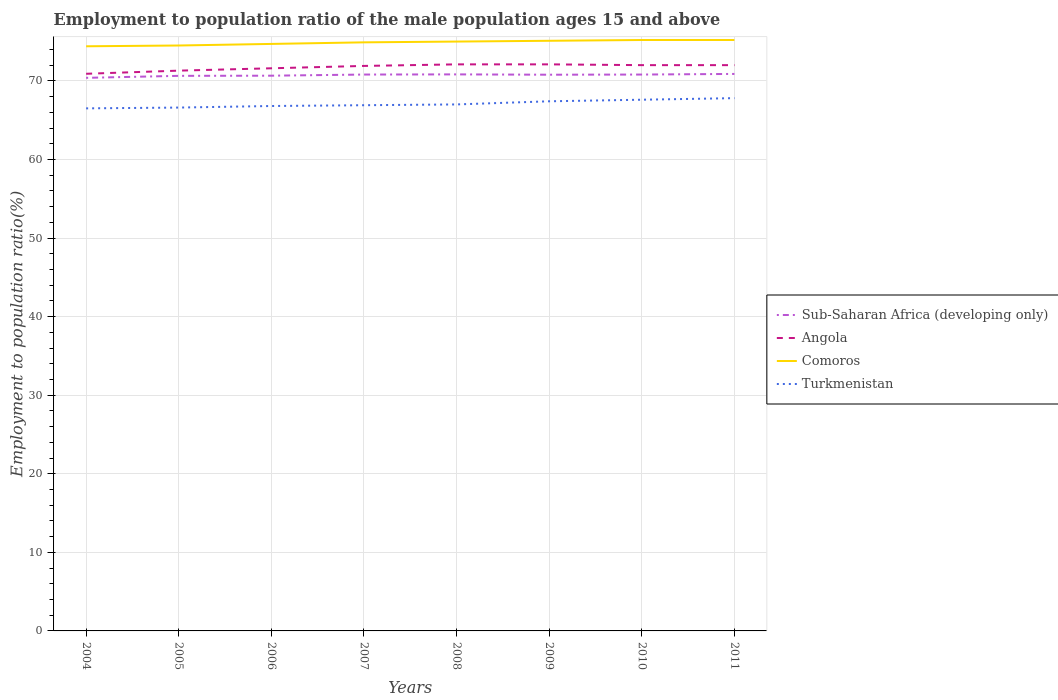How many different coloured lines are there?
Your response must be concise. 4. Does the line corresponding to Comoros intersect with the line corresponding to Angola?
Offer a terse response. No. Is the number of lines equal to the number of legend labels?
Offer a very short reply. Yes. Across all years, what is the maximum employment to population ratio in Sub-Saharan Africa (developing only)?
Make the answer very short. 70.38. In which year was the employment to population ratio in Sub-Saharan Africa (developing only) maximum?
Offer a very short reply. 2004. What is the difference between the highest and the second highest employment to population ratio in Turkmenistan?
Provide a succinct answer. 1.3. Is the employment to population ratio in Sub-Saharan Africa (developing only) strictly greater than the employment to population ratio in Comoros over the years?
Give a very brief answer. Yes. How many lines are there?
Provide a succinct answer. 4. How many years are there in the graph?
Offer a very short reply. 8. What is the difference between two consecutive major ticks on the Y-axis?
Offer a very short reply. 10. Does the graph contain any zero values?
Provide a succinct answer. No. Does the graph contain grids?
Keep it short and to the point. Yes. What is the title of the graph?
Provide a succinct answer. Employment to population ratio of the male population ages 15 and above. Does "Nepal" appear as one of the legend labels in the graph?
Make the answer very short. No. What is the label or title of the X-axis?
Your response must be concise. Years. What is the Employment to population ratio(%) in Sub-Saharan Africa (developing only) in 2004?
Provide a short and direct response. 70.38. What is the Employment to population ratio(%) in Angola in 2004?
Provide a succinct answer. 70.9. What is the Employment to population ratio(%) in Comoros in 2004?
Give a very brief answer. 74.4. What is the Employment to population ratio(%) in Turkmenistan in 2004?
Provide a succinct answer. 66.5. What is the Employment to population ratio(%) in Sub-Saharan Africa (developing only) in 2005?
Give a very brief answer. 70.64. What is the Employment to population ratio(%) of Angola in 2005?
Your response must be concise. 71.3. What is the Employment to population ratio(%) of Comoros in 2005?
Provide a short and direct response. 74.5. What is the Employment to population ratio(%) of Turkmenistan in 2005?
Give a very brief answer. 66.6. What is the Employment to population ratio(%) of Sub-Saharan Africa (developing only) in 2006?
Your answer should be very brief. 70.66. What is the Employment to population ratio(%) of Angola in 2006?
Your answer should be very brief. 71.6. What is the Employment to population ratio(%) of Comoros in 2006?
Keep it short and to the point. 74.7. What is the Employment to population ratio(%) of Turkmenistan in 2006?
Ensure brevity in your answer.  66.8. What is the Employment to population ratio(%) of Sub-Saharan Africa (developing only) in 2007?
Give a very brief answer. 70.8. What is the Employment to population ratio(%) of Angola in 2007?
Your response must be concise. 71.9. What is the Employment to population ratio(%) in Comoros in 2007?
Make the answer very short. 74.9. What is the Employment to population ratio(%) in Turkmenistan in 2007?
Make the answer very short. 66.9. What is the Employment to population ratio(%) of Sub-Saharan Africa (developing only) in 2008?
Ensure brevity in your answer.  70.82. What is the Employment to population ratio(%) of Angola in 2008?
Offer a very short reply. 72.1. What is the Employment to population ratio(%) in Comoros in 2008?
Provide a succinct answer. 75. What is the Employment to population ratio(%) in Sub-Saharan Africa (developing only) in 2009?
Your answer should be compact. 70.78. What is the Employment to population ratio(%) in Angola in 2009?
Offer a terse response. 72.1. What is the Employment to population ratio(%) of Comoros in 2009?
Provide a short and direct response. 75.1. What is the Employment to population ratio(%) in Turkmenistan in 2009?
Keep it short and to the point. 67.4. What is the Employment to population ratio(%) of Sub-Saharan Africa (developing only) in 2010?
Ensure brevity in your answer.  70.8. What is the Employment to population ratio(%) in Angola in 2010?
Ensure brevity in your answer.  72. What is the Employment to population ratio(%) in Comoros in 2010?
Provide a succinct answer. 75.2. What is the Employment to population ratio(%) of Turkmenistan in 2010?
Provide a succinct answer. 67.6. What is the Employment to population ratio(%) of Sub-Saharan Africa (developing only) in 2011?
Your response must be concise. 70.88. What is the Employment to population ratio(%) in Angola in 2011?
Provide a short and direct response. 72. What is the Employment to population ratio(%) in Comoros in 2011?
Offer a very short reply. 75.2. What is the Employment to population ratio(%) of Turkmenistan in 2011?
Offer a terse response. 67.8. Across all years, what is the maximum Employment to population ratio(%) in Sub-Saharan Africa (developing only)?
Provide a short and direct response. 70.88. Across all years, what is the maximum Employment to population ratio(%) in Angola?
Give a very brief answer. 72.1. Across all years, what is the maximum Employment to population ratio(%) in Comoros?
Provide a short and direct response. 75.2. Across all years, what is the maximum Employment to population ratio(%) in Turkmenistan?
Your answer should be compact. 67.8. Across all years, what is the minimum Employment to population ratio(%) in Sub-Saharan Africa (developing only)?
Your response must be concise. 70.38. Across all years, what is the minimum Employment to population ratio(%) in Angola?
Your answer should be very brief. 70.9. Across all years, what is the minimum Employment to population ratio(%) of Comoros?
Ensure brevity in your answer.  74.4. Across all years, what is the minimum Employment to population ratio(%) in Turkmenistan?
Your response must be concise. 66.5. What is the total Employment to population ratio(%) of Sub-Saharan Africa (developing only) in the graph?
Make the answer very short. 565.77. What is the total Employment to population ratio(%) of Angola in the graph?
Offer a terse response. 573.9. What is the total Employment to population ratio(%) in Comoros in the graph?
Ensure brevity in your answer.  599. What is the total Employment to population ratio(%) of Turkmenistan in the graph?
Give a very brief answer. 536.6. What is the difference between the Employment to population ratio(%) of Sub-Saharan Africa (developing only) in 2004 and that in 2005?
Ensure brevity in your answer.  -0.25. What is the difference between the Employment to population ratio(%) in Comoros in 2004 and that in 2005?
Your response must be concise. -0.1. What is the difference between the Employment to population ratio(%) in Sub-Saharan Africa (developing only) in 2004 and that in 2006?
Your response must be concise. -0.27. What is the difference between the Employment to population ratio(%) in Comoros in 2004 and that in 2006?
Offer a very short reply. -0.3. What is the difference between the Employment to population ratio(%) in Turkmenistan in 2004 and that in 2006?
Make the answer very short. -0.3. What is the difference between the Employment to population ratio(%) in Sub-Saharan Africa (developing only) in 2004 and that in 2007?
Offer a very short reply. -0.42. What is the difference between the Employment to population ratio(%) of Angola in 2004 and that in 2007?
Provide a short and direct response. -1. What is the difference between the Employment to population ratio(%) of Turkmenistan in 2004 and that in 2007?
Give a very brief answer. -0.4. What is the difference between the Employment to population ratio(%) in Sub-Saharan Africa (developing only) in 2004 and that in 2008?
Give a very brief answer. -0.44. What is the difference between the Employment to population ratio(%) in Angola in 2004 and that in 2008?
Your response must be concise. -1.2. What is the difference between the Employment to population ratio(%) of Sub-Saharan Africa (developing only) in 2004 and that in 2009?
Your answer should be compact. -0.4. What is the difference between the Employment to population ratio(%) in Comoros in 2004 and that in 2009?
Your response must be concise. -0.7. What is the difference between the Employment to population ratio(%) in Turkmenistan in 2004 and that in 2009?
Keep it short and to the point. -0.9. What is the difference between the Employment to population ratio(%) in Sub-Saharan Africa (developing only) in 2004 and that in 2010?
Give a very brief answer. -0.42. What is the difference between the Employment to population ratio(%) of Angola in 2004 and that in 2010?
Your answer should be very brief. -1.1. What is the difference between the Employment to population ratio(%) of Turkmenistan in 2004 and that in 2010?
Offer a very short reply. -1.1. What is the difference between the Employment to population ratio(%) of Sub-Saharan Africa (developing only) in 2004 and that in 2011?
Your answer should be compact. -0.5. What is the difference between the Employment to population ratio(%) of Angola in 2004 and that in 2011?
Your answer should be very brief. -1.1. What is the difference between the Employment to population ratio(%) of Sub-Saharan Africa (developing only) in 2005 and that in 2006?
Give a very brief answer. -0.02. What is the difference between the Employment to population ratio(%) of Sub-Saharan Africa (developing only) in 2005 and that in 2007?
Offer a terse response. -0.17. What is the difference between the Employment to population ratio(%) in Comoros in 2005 and that in 2007?
Give a very brief answer. -0.4. What is the difference between the Employment to population ratio(%) in Turkmenistan in 2005 and that in 2007?
Ensure brevity in your answer.  -0.3. What is the difference between the Employment to population ratio(%) of Sub-Saharan Africa (developing only) in 2005 and that in 2008?
Offer a very short reply. -0.19. What is the difference between the Employment to population ratio(%) of Angola in 2005 and that in 2008?
Offer a terse response. -0.8. What is the difference between the Employment to population ratio(%) in Turkmenistan in 2005 and that in 2008?
Offer a very short reply. -0.4. What is the difference between the Employment to population ratio(%) of Sub-Saharan Africa (developing only) in 2005 and that in 2009?
Give a very brief answer. -0.14. What is the difference between the Employment to population ratio(%) in Comoros in 2005 and that in 2009?
Ensure brevity in your answer.  -0.6. What is the difference between the Employment to population ratio(%) of Turkmenistan in 2005 and that in 2009?
Provide a short and direct response. -0.8. What is the difference between the Employment to population ratio(%) of Sub-Saharan Africa (developing only) in 2005 and that in 2010?
Your answer should be very brief. -0.17. What is the difference between the Employment to population ratio(%) of Angola in 2005 and that in 2010?
Provide a short and direct response. -0.7. What is the difference between the Employment to population ratio(%) in Sub-Saharan Africa (developing only) in 2005 and that in 2011?
Provide a short and direct response. -0.24. What is the difference between the Employment to population ratio(%) of Turkmenistan in 2005 and that in 2011?
Keep it short and to the point. -1.2. What is the difference between the Employment to population ratio(%) of Sub-Saharan Africa (developing only) in 2006 and that in 2007?
Your answer should be compact. -0.15. What is the difference between the Employment to population ratio(%) of Comoros in 2006 and that in 2007?
Ensure brevity in your answer.  -0.2. What is the difference between the Employment to population ratio(%) of Sub-Saharan Africa (developing only) in 2006 and that in 2008?
Your response must be concise. -0.17. What is the difference between the Employment to population ratio(%) of Comoros in 2006 and that in 2008?
Offer a very short reply. -0.3. What is the difference between the Employment to population ratio(%) in Sub-Saharan Africa (developing only) in 2006 and that in 2009?
Make the answer very short. -0.12. What is the difference between the Employment to population ratio(%) in Angola in 2006 and that in 2009?
Offer a terse response. -0.5. What is the difference between the Employment to population ratio(%) in Comoros in 2006 and that in 2009?
Provide a short and direct response. -0.4. What is the difference between the Employment to population ratio(%) in Turkmenistan in 2006 and that in 2009?
Offer a terse response. -0.6. What is the difference between the Employment to population ratio(%) in Sub-Saharan Africa (developing only) in 2006 and that in 2010?
Give a very brief answer. -0.15. What is the difference between the Employment to population ratio(%) in Comoros in 2006 and that in 2010?
Make the answer very short. -0.5. What is the difference between the Employment to population ratio(%) of Turkmenistan in 2006 and that in 2010?
Your answer should be very brief. -0.8. What is the difference between the Employment to population ratio(%) of Sub-Saharan Africa (developing only) in 2006 and that in 2011?
Ensure brevity in your answer.  -0.22. What is the difference between the Employment to population ratio(%) in Angola in 2006 and that in 2011?
Your response must be concise. -0.4. What is the difference between the Employment to population ratio(%) in Sub-Saharan Africa (developing only) in 2007 and that in 2008?
Offer a very short reply. -0.02. What is the difference between the Employment to population ratio(%) in Angola in 2007 and that in 2008?
Your answer should be compact. -0.2. What is the difference between the Employment to population ratio(%) in Turkmenistan in 2007 and that in 2008?
Give a very brief answer. -0.1. What is the difference between the Employment to population ratio(%) of Sub-Saharan Africa (developing only) in 2007 and that in 2009?
Your response must be concise. 0.02. What is the difference between the Employment to population ratio(%) in Angola in 2007 and that in 2009?
Make the answer very short. -0.2. What is the difference between the Employment to population ratio(%) of Sub-Saharan Africa (developing only) in 2007 and that in 2010?
Offer a terse response. -0. What is the difference between the Employment to population ratio(%) of Comoros in 2007 and that in 2010?
Keep it short and to the point. -0.3. What is the difference between the Employment to population ratio(%) in Sub-Saharan Africa (developing only) in 2007 and that in 2011?
Keep it short and to the point. -0.08. What is the difference between the Employment to population ratio(%) of Turkmenistan in 2007 and that in 2011?
Your answer should be very brief. -0.9. What is the difference between the Employment to population ratio(%) in Sub-Saharan Africa (developing only) in 2008 and that in 2009?
Provide a succinct answer. 0.04. What is the difference between the Employment to population ratio(%) of Angola in 2008 and that in 2009?
Provide a succinct answer. 0. What is the difference between the Employment to population ratio(%) in Turkmenistan in 2008 and that in 2009?
Your response must be concise. -0.4. What is the difference between the Employment to population ratio(%) of Sub-Saharan Africa (developing only) in 2008 and that in 2010?
Give a very brief answer. 0.02. What is the difference between the Employment to population ratio(%) of Angola in 2008 and that in 2010?
Make the answer very short. 0.1. What is the difference between the Employment to population ratio(%) of Turkmenistan in 2008 and that in 2010?
Give a very brief answer. -0.6. What is the difference between the Employment to population ratio(%) of Sub-Saharan Africa (developing only) in 2008 and that in 2011?
Provide a succinct answer. -0.06. What is the difference between the Employment to population ratio(%) in Angola in 2008 and that in 2011?
Provide a succinct answer. 0.1. What is the difference between the Employment to population ratio(%) of Sub-Saharan Africa (developing only) in 2009 and that in 2010?
Your response must be concise. -0.02. What is the difference between the Employment to population ratio(%) of Comoros in 2009 and that in 2010?
Your response must be concise. -0.1. What is the difference between the Employment to population ratio(%) in Sub-Saharan Africa (developing only) in 2009 and that in 2011?
Keep it short and to the point. -0.1. What is the difference between the Employment to population ratio(%) of Sub-Saharan Africa (developing only) in 2010 and that in 2011?
Provide a short and direct response. -0.08. What is the difference between the Employment to population ratio(%) of Angola in 2010 and that in 2011?
Your answer should be very brief. 0. What is the difference between the Employment to population ratio(%) in Sub-Saharan Africa (developing only) in 2004 and the Employment to population ratio(%) in Angola in 2005?
Keep it short and to the point. -0.92. What is the difference between the Employment to population ratio(%) in Sub-Saharan Africa (developing only) in 2004 and the Employment to population ratio(%) in Comoros in 2005?
Offer a terse response. -4.12. What is the difference between the Employment to population ratio(%) of Sub-Saharan Africa (developing only) in 2004 and the Employment to population ratio(%) of Turkmenistan in 2005?
Your response must be concise. 3.78. What is the difference between the Employment to population ratio(%) in Angola in 2004 and the Employment to population ratio(%) in Comoros in 2005?
Offer a very short reply. -3.6. What is the difference between the Employment to population ratio(%) of Sub-Saharan Africa (developing only) in 2004 and the Employment to population ratio(%) of Angola in 2006?
Offer a terse response. -1.22. What is the difference between the Employment to population ratio(%) in Sub-Saharan Africa (developing only) in 2004 and the Employment to population ratio(%) in Comoros in 2006?
Your response must be concise. -4.32. What is the difference between the Employment to population ratio(%) in Sub-Saharan Africa (developing only) in 2004 and the Employment to population ratio(%) in Turkmenistan in 2006?
Ensure brevity in your answer.  3.58. What is the difference between the Employment to population ratio(%) of Comoros in 2004 and the Employment to population ratio(%) of Turkmenistan in 2006?
Provide a succinct answer. 7.6. What is the difference between the Employment to population ratio(%) of Sub-Saharan Africa (developing only) in 2004 and the Employment to population ratio(%) of Angola in 2007?
Offer a very short reply. -1.52. What is the difference between the Employment to population ratio(%) of Sub-Saharan Africa (developing only) in 2004 and the Employment to population ratio(%) of Comoros in 2007?
Ensure brevity in your answer.  -4.52. What is the difference between the Employment to population ratio(%) in Sub-Saharan Africa (developing only) in 2004 and the Employment to population ratio(%) in Turkmenistan in 2007?
Keep it short and to the point. 3.48. What is the difference between the Employment to population ratio(%) in Angola in 2004 and the Employment to population ratio(%) in Comoros in 2007?
Give a very brief answer. -4. What is the difference between the Employment to population ratio(%) of Angola in 2004 and the Employment to population ratio(%) of Turkmenistan in 2007?
Provide a succinct answer. 4. What is the difference between the Employment to population ratio(%) of Comoros in 2004 and the Employment to population ratio(%) of Turkmenistan in 2007?
Your answer should be compact. 7.5. What is the difference between the Employment to population ratio(%) of Sub-Saharan Africa (developing only) in 2004 and the Employment to population ratio(%) of Angola in 2008?
Your response must be concise. -1.72. What is the difference between the Employment to population ratio(%) of Sub-Saharan Africa (developing only) in 2004 and the Employment to population ratio(%) of Comoros in 2008?
Your answer should be compact. -4.62. What is the difference between the Employment to population ratio(%) of Sub-Saharan Africa (developing only) in 2004 and the Employment to population ratio(%) of Turkmenistan in 2008?
Make the answer very short. 3.38. What is the difference between the Employment to population ratio(%) of Angola in 2004 and the Employment to population ratio(%) of Comoros in 2008?
Offer a terse response. -4.1. What is the difference between the Employment to population ratio(%) of Angola in 2004 and the Employment to population ratio(%) of Turkmenistan in 2008?
Provide a short and direct response. 3.9. What is the difference between the Employment to population ratio(%) in Sub-Saharan Africa (developing only) in 2004 and the Employment to population ratio(%) in Angola in 2009?
Provide a succinct answer. -1.72. What is the difference between the Employment to population ratio(%) in Sub-Saharan Africa (developing only) in 2004 and the Employment to population ratio(%) in Comoros in 2009?
Your answer should be compact. -4.72. What is the difference between the Employment to population ratio(%) of Sub-Saharan Africa (developing only) in 2004 and the Employment to population ratio(%) of Turkmenistan in 2009?
Ensure brevity in your answer.  2.98. What is the difference between the Employment to population ratio(%) in Angola in 2004 and the Employment to population ratio(%) in Comoros in 2009?
Your answer should be very brief. -4.2. What is the difference between the Employment to population ratio(%) in Comoros in 2004 and the Employment to population ratio(%) in Turkmenistan in 2009?
Offer a very short reply. 7. What is the difference between the Employment to population ratio(%) of Sub-Saharan Africa (developing only) in 2004 and the Employment to population ratio(%) of Angola in 2010?
Make the answer very short. -1.62. What is the difference between the Employment to population ratio(%) in Sub-Saharan Africa (developing only) in 2004 and the Employment to population ratio(%) in Comoros in 2010?
Your response must be concise. -4.82. What is the difference between the Employment to population ratio(%) in Sub-Saharan Africa (developing only) in 2004 and the Employment to population ratio(%) in Turkmenistan in 2010?
Provide a short and direct response. 2.78. What is the difference between the Employment to population ratio(%) in Angola in 2004 and the Employment to population ratio(%) in Turkmenistan in 2010?
Ensure brevity in your answer.  3.3. What is the difference between the Employment to population ratio(%) in Comoros in 2004 and the Employment to population ratio(%) in Turkmenistan in 2010?
Make the answer very short. 6.8. What is the difference between the Employment to population ratio(%) of Sub-Saharan Africa (developing only) in 2004 and the Employment to population ratio(%) of Angola in 2011?
Ensure brevity in your answer.  -1.62. What is the difference between the Employment to population ratio(%) in Sub-Saharan Africa (developing only) in 2004 and the Employment to population ratio(%) in Comoros in 2011?
Keep it short and to the point. -4.82. What is the difference between the Employment to population ratio(%) in Sub-Saharan Africa (developing only) in 2004 and the Employment to population ratio(%) in Turkmenistan in 2011?
Give a very brief answer. 2.58. What is the difference between the Employment to population ratio(%) of Sub-Saharan Africa (developing only) in 2005 and the Employment to population ratio(%) of Angola in 2006?
Provide a succinct answer. -0.96. What is the difference between the Employment to population ratio(%) of Sub-Saharan Africa (developing only) in 2005 and the Employment to population ratio(%) of Comoros in 2006?
Your answer should be compact. -4.06. What is the difference between the Employment to population ratio(%) of Sub-Saharan Africa (developing only) in 2005 and the Employment to population ratio(%) of Turkmenistan in 2006?
Keep it short and to the point. 3.84. What is the difference between the Employment to population ratio(%) of Angola in 2005 and the Employment to population ratio(%) of Comoros in 2006?
Make the answer very short. -3.4. What is the difference between the Employment to population ratio(%) of Comoros in 2005 and the Employment to population ratio(%) of Turkmenistan in 2006?
Ensure brevity in your answer.  7.7. What is the difference between the Employment to population ratio(%) in Sub-Saharan Africa (developing only) in 2005 and the Employment to population ratio(%) in Angola in 2007?
Offer a terse response. -1.26. What is the difference between the Employment to population ratio(%) of Sub-Saharan Africa (developing only) in 2005 and the Employment to population ratio(%) of Comoros in 2007?
Keep it short and to the point. -4.26. What is the difference between the Employment to population ratio(%) in Sub-Saharan Africa (developing only) in 2005 and the Employment to population ratio(%) in Turkmenistan in 2007?
Keep it short and to the point. 3.74. What is the difference between the Employment to population ratio(%) in Angola in 2005 and the Employment to population ratio(%) in Turkmenistan in 2007?
Provide a succinct answer. 4.4. What is the difference between the Employment to population ratio(%) in Sub-Saharan Africa (developing only) in 2005 and the Employment to population ratio(%) in Angola in 2008?
Ensure brevity in your answer.  -1.46. What is the difference between the Employment to population ratio(%) of Sub-Saharan Africa (developing only) in 2005 and the Employment to population ratio(%) of Comoros in 2008?
Your response must be concise. -4.36. What is the difference between the Employment to population ratio(%) of Sub-Saharan Africa (developing only) in 2005 and the Employment to population ratio(%) of Turkmenistan in 2008?
Keep it short and to the point. 3.64. What is the difference between the Employment to population ratio(%) of Angola in 2005 and the Employment to population ratio(%) of Turkmenistan in 2008?
Provide a succinct answer. 4.3. What is the difference between the Employment to population ratio(%) in Comoros in 2005 and the Employment to population ratio(%) in Turkmenistan in 2008?
Your answer should be very brief. 7.5. What is the difference between the Employment to population ratio(%) in Sub-Saharan Africa (developing only) in 2005 and the Employment to population ratio(%) in Angola in 2009?
Your answer should be very brief. -1.46. What is the difference between the Employment to population ratio(%) in Sub-Saharan Africa (developing only) in 2005 and the Employment to population ratio(%) in Comoros in 2009?
Give a very brief answer. -4.46. What is the difference between the Employment to population ratio(%) of Sub-Saharan Africa (developing only) in 2005 and the Employment to population ratio(%) of Turkmenistan in 2009?
Offer a very short reply. 3.24. What is the difference between the Employment to population ratio(%) of Angola in 2005 and the Employment to population ratio(%) of Comoros in 2009?
Keep it short and to the point. -3.8. What is the difference between the Employment to population ratio(%) in Sub-Saharan Africa (developing only) in 2005 and the Employment to population ratio(%) in Angola in 2010?
Your answer should be very brief. -1.36. What is the difference between the Employment to population ratio(%) in Sub-Saharan Africa (developing only) in 2005 and the Employment to population ratio(%) in Comoros in 2010?
Provide a short and direct response. -4.56. What is the difference between the Employment to population ratio(%) of Sub-Saharan Africa (developing only) in 2005 and the Employment to population ratio(%) of Turkmenistan in 2010?
Offer a terse response. 3.04. What is the difference between the Employment to population ratio(%) of Angola in 2005 and the Employment to population ratio(%) of Comoros in 2010?
Ensure brevity in your answer.  -3.9. What is the difference between the Employment to population ratio(%) of Comoros in 2005 and the Employment to population ratio(%) of Turkmenistan in 2010?
Offer a very short reply. 6.9. What is the difference between the Employment to population ratio(%) in Sub-Saharan Africa (developing only) in 2005 and the Employment to population ratio(%) in Angola in 2011?
Give a very brief answer. -1.36. What is the difference between the Employment to population ratio(%) of Sub-Saharan Africa (developing only) in 2005 and the Employment to population ratio(%) of Comoros in 2011?
Offer a terse response. -4.56. What is the difference between the Employment to population ratio(%) of Sub-Saharan Africa (developing only) in 2005 and the Employment to population ratio(%) of Turkmenistan in 2011?
Your response must be concise. 2.84. What is the difference between the Employment to population ratio(%) of Angola in 2005 and the Employment to population ratio(%) of Comoros in 2011?
Your answer should be compact. -3.9. What is the difference between the Employment to population ratio(%) in Comoros in 2005 and the Employment to population ratio(%) in Turkmenistan in 2011?
Your response must be concise. 6.7. What is the difference between the Employment to population ratio(%) of Sub-Saharan Africa (developing only) in 2006 and the Employment to population ratio(%) of Angola in 2007?
Your response must be concise. -1.24. What is the difference between the Employment to population ratio(%) of Sub-Saharan Africa (developing only) in 2006 and the Employment to population ratio(%) of Comoros in 2007?
Keep it short and to the point. -4.24. What is the difference between the Employment to population ratio(%) in Sub-Saharan Africa (developing only) in 2006 and the Employment to population ratio(%) in Turkmenistan in 2007?
Provide a succinct answer. 3.76. What is the difference between the Employment to population ratio(%) of Angola in 2006 and the Employment to population ratio(%) of Comoros in 2007?
Ensure brevity in your answer.  -3.3. What is the difference between the Employment to population ratio(%) in Angola in 2006 and the Employment to population ratio(%) in Turkmenistan in 2007?
Provide a short and direct response. 4.7. What is the difference between the Employment to population ratio(%) in Comoros in 2006 and the Employment to population ratio(%) in Turkmenistan in 2007?
Offer a very short reply. 7.8. What is the difference between the Employment to population ratio(%) of Sub-Saharan Africa (developing only) in 2006 and the Employment to population ratio(%) of Angola in 2008?
Provide a short and direct response. -1.44. What is the difference between the Employment to population ratio(%) of Sub-Saharan Africa (developing only) in 2006 and the Employment to population ratio(%) of Comoros in 2008?
Offer a very short reply. -4.34. What is the difference between the Employment to population ratio(%) in Sub-Saharan Africa (developing only) in 2006 and the Employment to population ratio(%) in Turkmenistan in 2008?
Keep it short and to the point. 3.66. What is the difference between the Employment to population ratio(%) in Sub-Saharan Africa (developing only) in 2006 and the Employment to population ratio(%) in Angola in 2009?
Your answer should be very brief. -1.44. What is the difference between the Employment to population ratio(%) of Sub-Saharan Africa (developing only) in 2006 and the Employment to population ratio(%) of Comoros in 2009?
Give a very brief answer. -4.44. What is the difference between the Employment to population ratio(%) in Sub-Saharan Africa (developing only) in 2006 and the Employment to population ratio(%) in Turkmenistan in 2009?
Ensure brevity in your answer.  3.26. What is the difference between the Employment to population ratio(%) in Angola in 2006 and the Employment to population ratio(%) in Comoros in 2009?
Provide a short and direct response. -3.5. What is the difference between the Employment to population ratio(%) in Angola in 2006 and the Employment to population ratio(%) in Turkmenistan in 2009?
Offer a terse response. 4.2. What is the difference between the Employment to population ratio(%) of Sub-Saharan Africa (developing only) in 2006 and the Employment to population ratio(%) of Angola in 2010?
Offer a terse response. -1.34. What is the difference between the Employment to population ratio(%) in Sub-Saharan Africa (developing only) in 2006 and the Employment to population ratio(%) in Comoros in 2010?
Your answer should be very brief. -4.54. What is the difference between the Employment to population ratio(%) of Sub-Saharan Africa (developing only) in 2006 and the Employment to population ratio(%) of Turkmenistan in 2010?
Your answer should be compact. 3.06. What is the difference between the Employment to population ratio(%) of Angola in 2006 and the Employment to population ratio(%) of Comoros in 2010?
Provide a short and direct response. -3.6. What is the difference between the Employment to population ratio(%) in Sub-Saharan Africa (developing only) in 2006 and the Employment to population ratio(%) in Angola in 2011?
Make the answer very short. -1.34. What is the difference between the Employment to population ratio(%) of Sub-Saharan Africa (developing only) in 2006 and the Employment to population ratio(%) of Comoros in 2011?
Your answer should be compact. -4.54. What is the difference between the Employment to population ratio(%) in Sub-Saharan Africa (developing only) in 2006 and the Employment to population ratio(%) in Turkmenistan in 2011?
Offer a very short reply. 2.86. What is the difference between the Employment to population ratio(%) in Comoros in 2006 and the Employment to population ratio(%) in Turkmenistan in 2011?
Make the answer very short. 6.9. What is the difference between the Employment to population ratio(%) in Sub-Saharan Africa (developing only) in 2007 and the Employment to population ratio(%) in Angola in 2008?
Make the answer very short. -1.3. What is the difference between the Employment to population ratio(%) in Sub-Saharan Africa (developing only) in 2007 and the Employment to population ratio(%) in Comoros in 2008?
Offer a terse response. -4.2. What is the difference between the Employment to population ratio(%) in Sub-Saharan Africa (developing only) in 2007 and the Employment to population ratio(%) in Turkmenistan in 2008?
Provide a short and direct response. 3.8. What is the difference between the Employment to population ratio(%) of Comoros in 2007 and the Employment to population ratio(%) of Turkmenistan in 2008?
Keep it short and to the point. 7.9. What is the difference between the Employment to population ratio(%) of Sub-Saharan Africa (developing only) in 2007 and the Employment to population ratio(%) of Angola in 2009?
Keep it short and to the point. -1.3. What is the difference between the Employment to population ratio(%) of Sub-Saharan Africa (developing only) in 2007 and the Employment to population ratio(%) of Comoros in 2009?
Ensure brevity in your answer.  -4.3. What is the difference between the Employment to population ratio(%) of Sub-Saharan Africa (developing only) in 2007 and the Employment to population ratio(%) of Turkmenistan in 2009?
Provide a short and direct response. 3.4. What is the difference between the Employment to population ratio(%) of Angola in 2007 and the Employment to population ratio(%) of Turkmenistan in 2009?
Give a very brief answer. 4.5. What is the difference between the Employment to population ratio(%) in Comoros in 2007 and the Employment to population ratio(%) in Turkmenistan in 2009?
Provide a short and direct response. 7.5. What is the difference between the Employment to population ratio(%) in Sub-Saharan Africa (developing only) in 2007 and the Employment to population ratio(%) in Angola in 2010?
Ensure brevity in your answer.  -1.2. What is the difference between the Employment to population ratio(%) of Sub-Saharan Africa (developing only) in 2007 and the Employment to population ratio(%) of Comoros in 2010?
Offer a terse response. -4.4. What is the difference between the Employment to population ratio(%) of Sub-Saharan Africa (developing only) in 2007 and the Employment to population ratio(%) of Turkmenistan in 2010?
Your answer should be very brief. 3.2. What is the difference between the Employment to population ratio(%) of Sub-Saharan Africa (developing only) in 2007 and the Employment to population ratio(%) of Angola in 2011?
Your response must be concise. -1.2. What is the difference between the Employment to population ratio(%) in Sub-Saharan Africa (developing only) in 2007 and the Employment to population ratio(%) in Comoros in 2011?
Provide a succinct answer. -4.4. What is the difference between the Employment to population ratio(%) of Sub-Saharan Africa (developing only) in 2007 and the Employment to population ratio(%) of Turkmenistan in 2011?
Your response must be concise. 3. What is the difference between the Employment to population ratio(%) in Comoros in 2007 and the Employment to population ratio(%) in Turkmenistan in 2011?
Provide a succinct answer. 7.1. What is the difference between the Employment to population ratio(%) of Sub-Saharan Africa (developing only) in 2008 and the Employment to population ratio(%) of Angola in 2009?
Offer a very short reply. -1.28. What is the difference between the Employment to population ratio(%) in Sub-Saharan Africa (developing only) in 2008 and the Employment to population ratio(%) in Comoros in 2009?
Offer a terse response. -4.28. What is the difference between the Employment to population ratio(%) in Sub-Saharan Africa (developing only) in 2008 and the Employment to population ratio(%) in Turkmenistan in 2009?
Your answer should be compact. 3.42. What is the difference between the Employment to population ratio(%) of Comoros in 2008 and the Employment to population ratio(%) of Turkmenistan in 2009?
Your answer should be very brief. 7.6. What is the difference between the Employment to population ratio(%) of Sub-Saharan Africa (developing only) in 2008 and the Employment to population ratio(%) of Angola in 2010?
Your answer should be very brief. -1.18. What is the difference between the Employment to population ratio(%) of Sub-Saharan Africa (developing only) in 2008 and the Employment to population ratio(%) of Comoros in 2010?
Your response must be concise. -4.38. What is the difference between the Employment to population ratio(%) in Sub-Saharan Africa (developing only) in 2008 and the Employment to population ratio(%) in Turkmenistan in 2010?
Keep it short and to the point. 3.22. What is the difference between the Employment to population ratio(%) of Angola in 2008 and the Employment to population ratio(%) of Turkmenistan in 2010?
Provide a short and direct response. 4.5. What is the difference between the Employment to population ratio(%) in Comoros in 2008 and the Employment to population ratio(%) in Turkmenistan in 2010?
Keep it short and to the point. 7.4. What is the difference between the Employment to population ratio(%) of Sub-Saharan Africa (developing only) in 2008 and the Employment to population ratio(%) of Angola in 2011?
Ensure brevity in your answer.  -1.18. What is the difference between the Employment to population ratio(%) in Sub-Saharan Africa (developing only) in 2008 and the Employment to population ratio(%) in Comoros in 2011?
Your answer should be compact. -4.38. What is the difference between the Employment to population ratio(%) in Sub-Saharan Africa (developing only) in 2008 and the Employment to population ratio(%) in Turkmenistan in 2011?
Ensure brevity in your answer.  3.02. What is the difference between the Employment to population ratio(%) in Angola in 2008 and the Employment to population ratio(%) in Turkmenistan in 2011?
Provide a succinct answer. 4.3. What is the difference between the Employment to population ratio(%) in Sub-Saharan Africa (developing only) in 2009 and the Employment to population ratio(%) in Angola in 2010?
Offer a terse response. -1.22. What is the difference between the Employment to population ratio(%) of Sub-Saharan Africa (developing only) in 2009 and the Employment to population ratio(%) of Comoros in 2010?
Your response must be concise. -4.42. What is the difference between the Employment to population ratio(%) of Sub-Saharan Africa (developing only) in 2009 and the Employment to population ratio(%) of Turkmenistan in 2010?
Make the answer very short. 3.18. What is the difference between the Employment to population ratio(%) in Angola in 2009 and the Employment to population ratio(%) in Comoros in 2010?
Ensure brevity in your answer.  -3.1. What is the difference between the Employment to population ratio(%) in Comoros in 2009 and the Employment to population ratio(%) in Turkmenistan in 2010?
Your answer should be very brief. 7.5. What is the difference between the Employment to population ratio(%) in Sub-Saharan Africa (developing only) in 2009 and the Employment to population ratio(%) in Angola in 2011?
Provide a succinct answer. -1.22. What is the difference between the Employment to population ratio(%) of Sub-Saharan Africa (developing only) in 2009 and the Employment to population ratio(%) of Comoros in 2011?
Provide a succinct answer. -4.42. What is the difference between the Employment to population ratio(%) of Sub-Saharan Africa (developing only) in 2009 and the Employment to population ratio(%) of Turkmenistan in 2011?
Provide a short and direct response. 2.98. What is the difference between the Employment to population ratio(%) of Angola in 2009 and the Employment to population ratio(%) of Comoros in 2011?
Your answer should be compact. -3.1. What is the difference between the Employment to population ratio(%) in Sub-Saharan Africa (developing only) in 2010 and the Employment to population ratio(%) in Angola in 2011?
Offer a very short reply. -1.2. What is the difference between the Employment to population ratio(%) of Sub-Saharan Africa (developing only) in 2010 and the Employment to population ratio(%) of Comoros in 2011?
Make the answer very short. -4.4. What is the difference between the Employment to population ratio(%) in Sub-Saharan Africa (developing only) in 2010 and the Employment to population ratio(%) in Turkmenistan in 2011?
Your answer should be compact. 3. What is the difference between the Employment to population ratio(%) of Angola in 2010 and the Employment to population ratio(%) of Turkmenistan in 2011?
Make the answer very short. 4.2. What is the difference between the Employment to population ratio(%) in Comoros in 2010 and the Employment to population ratio(%) in Turkmenistan in 2011?
Your response must be concise. 7.4. What is the average Employment to population ratio(%) of Sub-Saharan Africa (developing only) per year?
Keep it short and to the point. 70.72. What is the average Employment to population ratio(%) in Angola per year?
Your answer should be very brief. 71.74. What is the average Employment to population ratio(%) in Comoros per year?
Make the answer very short. 74.88. What is the average Employment to population ratio(%) of Turkmenistan per year?
Offer a terse response. 67.08. In the year 2004, what is the difference between the Employment to population ratio(%) of Sub-Saharan Africa (developing only) and Employment to population ratio(%) of Angola?
Your answer should be very brief. -0.52. In the year 2004, what is the difference between the Employment to population ratio(%) of Sub-Saharan Africa (developing only) and Employment to population ratio(%) of Comoros?
Offer a terse response. -4.02. In the year 2004, what is the difference between the Employment to population ratio(%) of Sub-Saharan Africa (developing only) and Employment to population ratio(%) of Turkmenistan?
Your response must be concise. 3.88. In the year 2004, what is the difference between the Employment to population ratio(%) of Angola and Employment to population ratio(%) of Turkmenistan?
Your answer should be compact. 4.4. In the year 2004, what is the difference between the Employment to population ratio(%) of Comoros and Employment to population ratio(%) of Turkmenistan?
Your answer should be very brief. 7.9. In the year 2005, what is the difference between the Employment to population ratio(%) in Sub-Saharan Africa (developing only) and Employment to population ratio(%) in Angola?
Your response must be concise. -0.66. In the year 2005, what is the difference between the Employment to population ratio(%) in Sub-Saharan Africa (developing only) and Employment to population ratio(%) in Comoros?
Your answer should be very brief. -3.86. In the year 2005, what is the difference between the Employment to population ratio(%) of Sub-Saharan Africa (developing only) and Employment to population ratio(%) of Turkmenistan?
Ensure brevity in your answer.  4.04. In the year 2005, what is the difference between the Employment to population ratio(%) in Angola and Employment to population ratio(%) in Comoros?
Provide a short and direct response. -3.2. In the year 2006, what is the difference between the Employment to population ratio(%) in Sub-Saharan Africa (developing only) and Employment to population ratio(%) in Angola?
Provide a succinct answer. -0.94. In the year 2006, what is the difference between the Employment to population ratio(%) of Sub-Saharan Africa (developing only) and Employment to population ratio(%) of Comoros?
Offer a very short reply. -4.04. In the year 2006, what is the difference between the Employment to population ratio(%) in Sub-Saharan Africa (developing only) and Employment to population ratio(%) in Turkmenistan?
Your answer should be compact. 3.86. In the year 2006, what is the difference between the Employment to population ratio(%) of Comoros and Employment to population ratio(%) of Turkmenistan?
Provide a succinct answer. 7.9. In the year 2007, what is the difference between the Employment to population ratio(%) of Sub-Saharan Africa (developing only) and Employment to population ratio(%) of Angola?
Your answer should be very brief. -1.1. In the year 2007, what is the difference between the Employment to population ratio(%) of Sub-Saharan Africa (developing only) and Employment to population ratio(%) of Comoros?
Ensure brevity in your answer.  -4.1. In the year 2007, what is the difference between the Employment to population ratio(%) of Sub-Saharan Africa (developing only) and Employment to population ratio(%) of Turkmenistan?
Your response must be concise. 3.9. In the year 2007, what is the difference between the Employment to population ratio(%) in Comoros and Employment to population ratio(%) in Turkmenistan?
Keep it short and to the point. 8. In the year 2008, what is the difference between the Employment to population ratio(%) of Sub-Saharan Africa (developing only) and Employment to population ratio(%) of Angola?
Offer a very short reply. -1.28. In the year 2008, what is the difference between the Employment to population ratio(%) of Sub-Saharan Africa (developing only) and Employment to population ratio(%) of Comoros?
Your answer should be compact. -4.18. In the year 2008, what is the difference between the Employment to population ratio(%) of Sub-Saharan Africa (developing only) and Employment to population ratio(%) of Turkmenistan?
Offer a very short reply. 3.82. In the year 2008, what is the difference between the Employment to population ratio(%) of Angola and Employment to population ratio(%) of Turkmenistan?
Provide a succinct answer. 5.1. In the year 2009, what is the difference between the Employment to population ratio(%) in Sub-Saharan Africa (developing only) and Employment to population ratio(%) in Angola?
Offer a very short reply. -1.32. In the year 2009, what is the difference between the Employment to population ratio(%) of Sub-Saharan Africa (developing only) and Employment to population ratio(%) of Comoros?
Your answer should be very brief. -4.32. In the year 2009, what is the difference between the Employment to population ratio(%) of Sub-Saharan Africa (developing only) and Employment to population ratio(%) of Turkmenistan?
Your response must be concise. 3.38. In the year 2009, what is the difference between the Employment to population ratio(%) of Angola and Employment to population ratio(%) of Turkmenistan?
Give a very brief answer. 4.7. In the year 2010, what is the difference between the Employment to population ratio(%) in Sub-Saharan Africa (developing only) and Employment to population ratio(%) in Angola?
Your response must be concise. -1.2. In the year 2010, what is the difference between the Employment to population ratio(%) of Sub-Saharan Africa (developing only) and Employment to population ratio(%) of Comoros?
Make the answer very short. -4.4. In the year 2010, what is the difference between the Employment to population ratio(%) of Sub-Saharan Africa (developing only) and Employment to population ratio(%) of Turkmenistan?
Your response must be concise. 3.2. In the year 2010, what is the difference between the Employment to population ratio(%) in Comoros and Employment to population ratio(%) in Turkmenistan?
Provide a succinct answer. 7.6. In the year 2011, what is the difference between the Employment to population ratio(%) of Sub-Saharan Africa (developing only) and Employment to population ratio(%) of Angola?
Your answer should be compact. -1.12. In the year 2011, what is the difference between the Employment to population ratio(%) of Sub-Saharan Africa (developing only) and Employment to population ratio(%) of Comoros?
Offer a very short reply. -4.32. In the year 2011, what is the difference between the Employment to population ratio(%) of Sub-Saharan Africa (developing only) and Employment to population ratio(%) of Turkmenistan?
Offer a very short reply. 3.08. In the year 2011, what is the difference between the Employment to population ratio(%) of Angola and Employment to population ratio(%) of Turkmenistan?
Offer a very short reply. 4.2. What is the ratio of the Employment to population ratio(%) of Sub-Saharan Africa (developing only) in 2004 to that in 2005?
Your answer should be very brief. 1. What is the ratio of the Employment to population ratio(%) in Turkmenistan in 2004 to that in 2005?
Your response must be concise. 1. What is the ratio of the Employment to population ratio(%) of Sub-Saharan Africa (developing only) in 2004 to that in 2006?
Ensure brevity in your answer.  1. What is the ratio of the Employment to population ratio(%) in Angola in 2004 to that in 2006?
Make the answer very short. 0.99. What is the ratio of the Employment to population ratio(%) of Comoros in 2004 to that in 2006?
Your answer should be very brief. 1. What is the ratio of the Employment to population ratio(%) of Sub-Saharan Africa (developing only) in 2004 to that in 2007?
Your answer should be very brief. 0.99. What is the ratio of the Employment to population ratio(%) of Angola in 2004 to that in 2007?
Your response must be concise. 0.99. What is the ratio of the Employment to population ratio(%) of Comoros in 2004 to that in 2007?
Ensure brevity in your answer.  0.99. What is the ratio of the Employment to population ratio(%) of Angola in 2004 to that in 2008?
Provide a short and direct response. 0.98. What is the ratio of the Employment to population ratio(%) of Angola in 2004 to that in 2009?
Give a very brief answer. 0.98. What is the ratio of the Employment to population ratio(%) of Comoros in 2004 to that in 2009?
Make the answer very short. 0.99. What is the ratio of the Employment to population ratio(%) in Turkmenistan in 2004 to that in 2009?
Offer a terse response. 0.99. What is the ratio of the Employment to population ratio(%) of Sub-Saharan Africa (developing only) in 2004 to that in 2010?
Give a very brief answer. 0.99. What is the ratio of the Employment to population ratio(%) in Angola in 2004 to that in 2010?
Provide a short and direct response. 0.98. What is the ratio of the Employment to population ratio(%) in Comoros in 2004 to that in 2010?
Your answer should be very brief. 0.99. What is the ratio of the Employment to population ratio(%) in Turkmenistan in 2004 to that in 2010?
Ensure brevity in your answer.  0.98. What is the ratio of the Employment to population ratio(%) in Sub-Saharan Africa (developing only) in 2004 to that in 2011?
Offer a very short reply. 0.99. What is the ratio of the Employment to population ratio(%) in Angola in 2004 to that in 2011?
Your answer should be compact. 0.98. What is the ratio of the Employment to population ratio(%) of Comoros in 2004 to that in 2011?
Make the answer very short. 0.99. What is the ratio of the Employment to population ratio(%) in Turkmenistan in 2004 to that in 2011?
Your answer should be compact. 0.98. What is the ratio of the Employment to population ratio(%) of Sub-Saharan Africa (developing only) in 2005 to that in 2006?
Your answer should be compact. 1. What is the ratio of the Employment to population ratio(%) in Angola in 2005 to that in 2006?
Give a very brief answer. 1. What is the ratio of the Employment to population ratio(%) of Angola in 2005 to that in 2008?
Offer a very short reply. 0.99. What is the ratio of the Employment to population ratio(%) of Turkmenistan in 2005 to that in 2008?
Make the answer very short. 0.99. What is the ratio of the Employment to population ratio(%) of Sub-Saharan Africa (developing only) in 2005 to that in 2009?
Ensure brevity in your answer.  1. What is the ratio of the Employment to population ratio(%) of Angola in 2005 to that in 2009?
Offer a terse response. 0.99. What is the ratio of the Employment to population ratio(%) of Comoros in 2005 to that in 2009?
Your answer should be very brief. 0.99. What is the ratio of the Employment to population ratio(%) of Angola in 2005 to that in 2010?
Offer a very short reply. 0.99. What is the ratio of the Employment to population ratio(%) in Turkmenistan in 2005 to that in 2010?
Provide a short and direct response. 0.99. What is the ratio of the Employment to population ratio(%) in Angola in 2005 to that in 2011?
Make the answer very short. 0.99. What is the ratio of the Employment to population ratio(%) in Turkmenistan in 2005 to that in 2011?
Your answer should be compact. 0.98. What is the ratio of the Employment to population ratio(%) of Comoros in 2006 to that in 2007?
Provide a short and direct response. 1. What is the ratio of the Employment to population ratio(%) in Turkmenistan in 2006 to that in 2007?
Keep it short and to the point. 1. What is the ratio of the Employment to population ratio(%) of Sub-Saharan Africa (developing only) in 2006 to that in 2008?
Ensure brevity in your answer.  1. What is the ratio of the Employment to population ratio(%) of Turkmenistan in 2006 to that in 2008?
Offer a very short reply. 1. What is the ratio of the Employment to population ratio(%) of Sub-Saharan Africa (developing only) in 2006 to that in 2010?
Your answer should be compact. 1. What is the ratio of the Employment to population ratio(%) of Comoros in 2006 to that in 2010?
Offer a very short reply. 0.99. What is the ratio of the Employment to population ratio(%) in Sub-Saharan Africa (developing only) in 2006 to that in 2011?
Offer a terse response. 1. What is the ratio of the Employment to population ratio(%) of Comoros in 2006 to that in 2011?
Give a very brief answer. 0.99. What is the ratio of the Employment to population ratio(%) of Angola in 2007 to that in 2009?
Your answer should be very brief. 1. What is the ratio of the Employment to population ratio(%) in Comoros in 2007 to that in 2009?
Provide a succinct answer. 1. What is the ratio of the Employment to population ratio(%) of Sub-Saharan Africa (developing only) in 2007 to that in 2010?
Offer a very short reply. 1. What is the ratio of the Employment to population ratio(%) in Comoros in 2007 to that in 2010?
Ensure brevity in your answer.  1. What is the ratio of the Employment to population ratio(%) in Turkmenistan in 2007 to that in 2010?
Provide a short and direct response. 0.99. What is the ratio of the Employment to population ratio(%) in Sub-Saharan Africa (developing only) in 2007 to that in 2011?
Ensure brevity in your answer.  1. What is the ratio of the Employment to population ratio(%) in Turkmenistan in 2007 to that in 2011?
Make the answer very short. 0.99. What is the ratio of the Employment to population ratio(%) of Comoros in 2008 to that in 2009?
Provide a short and direct response. 1. What is the ratio of the Employment to population ratio(%) of Turkmenistan in 2008 to that in 2009?
Keep it short and to the point. 0.99. What is the ratio of the Employment to population ratio(%) in Sub-Saharan Africa (developing only) in 2008 to that in 2010?
Give a very brief answer. 1. What is the ratio of the Employment to population ratio(%) of Angola in 2008 to that in 2010?
Give a very brief answer. 1. What is the ratio of the Employment to population ratio(%) in Comoros in 2008 to that in 2010?
Your answer should be compact. 1. What is the ratio of the Employment to population ratio(%) in Angola in 2008 to that in 2011?
Provide a succinct answer. 1. What is the ratio of the Employment to population ratio(%) in Comoros in 2008 to that in 2011?
Give a very brief answer. 1. What is the ratio of the Employment to population ratio(%) of Angola in 2009 to that in 2010?
Your answer should be compact. 1. What is the ratio of the Employment to population ratio(%) of Comoros in 2009 to that in 2010?
Offer a very short reply. 1. What is the ratio of the Employment to population ratio(%) of Turkmenistan in 2009 to that in 2010?
Ensure brevity in your answer.  1. What is the ratio of the Employment to population ratio(%) in Angola in 2009 to that in 2011?
Ensure brevity in your answer.  1. What is the ratio of the Employment to population ratio(%) in Comoros in 2010 to that in 2011?
Keep it short and to the point. 1. What is the ratio of the Employment to population ratio(%) in Turkmenistan in 2010 to that in 2011?
Provide a short and direct response. 1. What is the difference between the highest and the second highest Employment to population ratio(%) in Sub-Saharan Africa (developing only)?
Provide a short and direct response. 0.06. What is the difference between the highest and the second highest Employment to population ratio(%) of Angola?
Keep it short and to the point. 0. What is the difference between the highest and the lowest Employment to population ratio(%) of Sub-Saharan Africa (developing only)?
Ensure brevity in your answer.  0.5. What is the difference between the highest and the lowest Employment to population ratio(%) in Angola?
Provide a succinct answer. 1.2. What is the difference between the highest and the lowest Employment to population ratio(%) of Comoros?
Your answer should be compact. 0.8. 